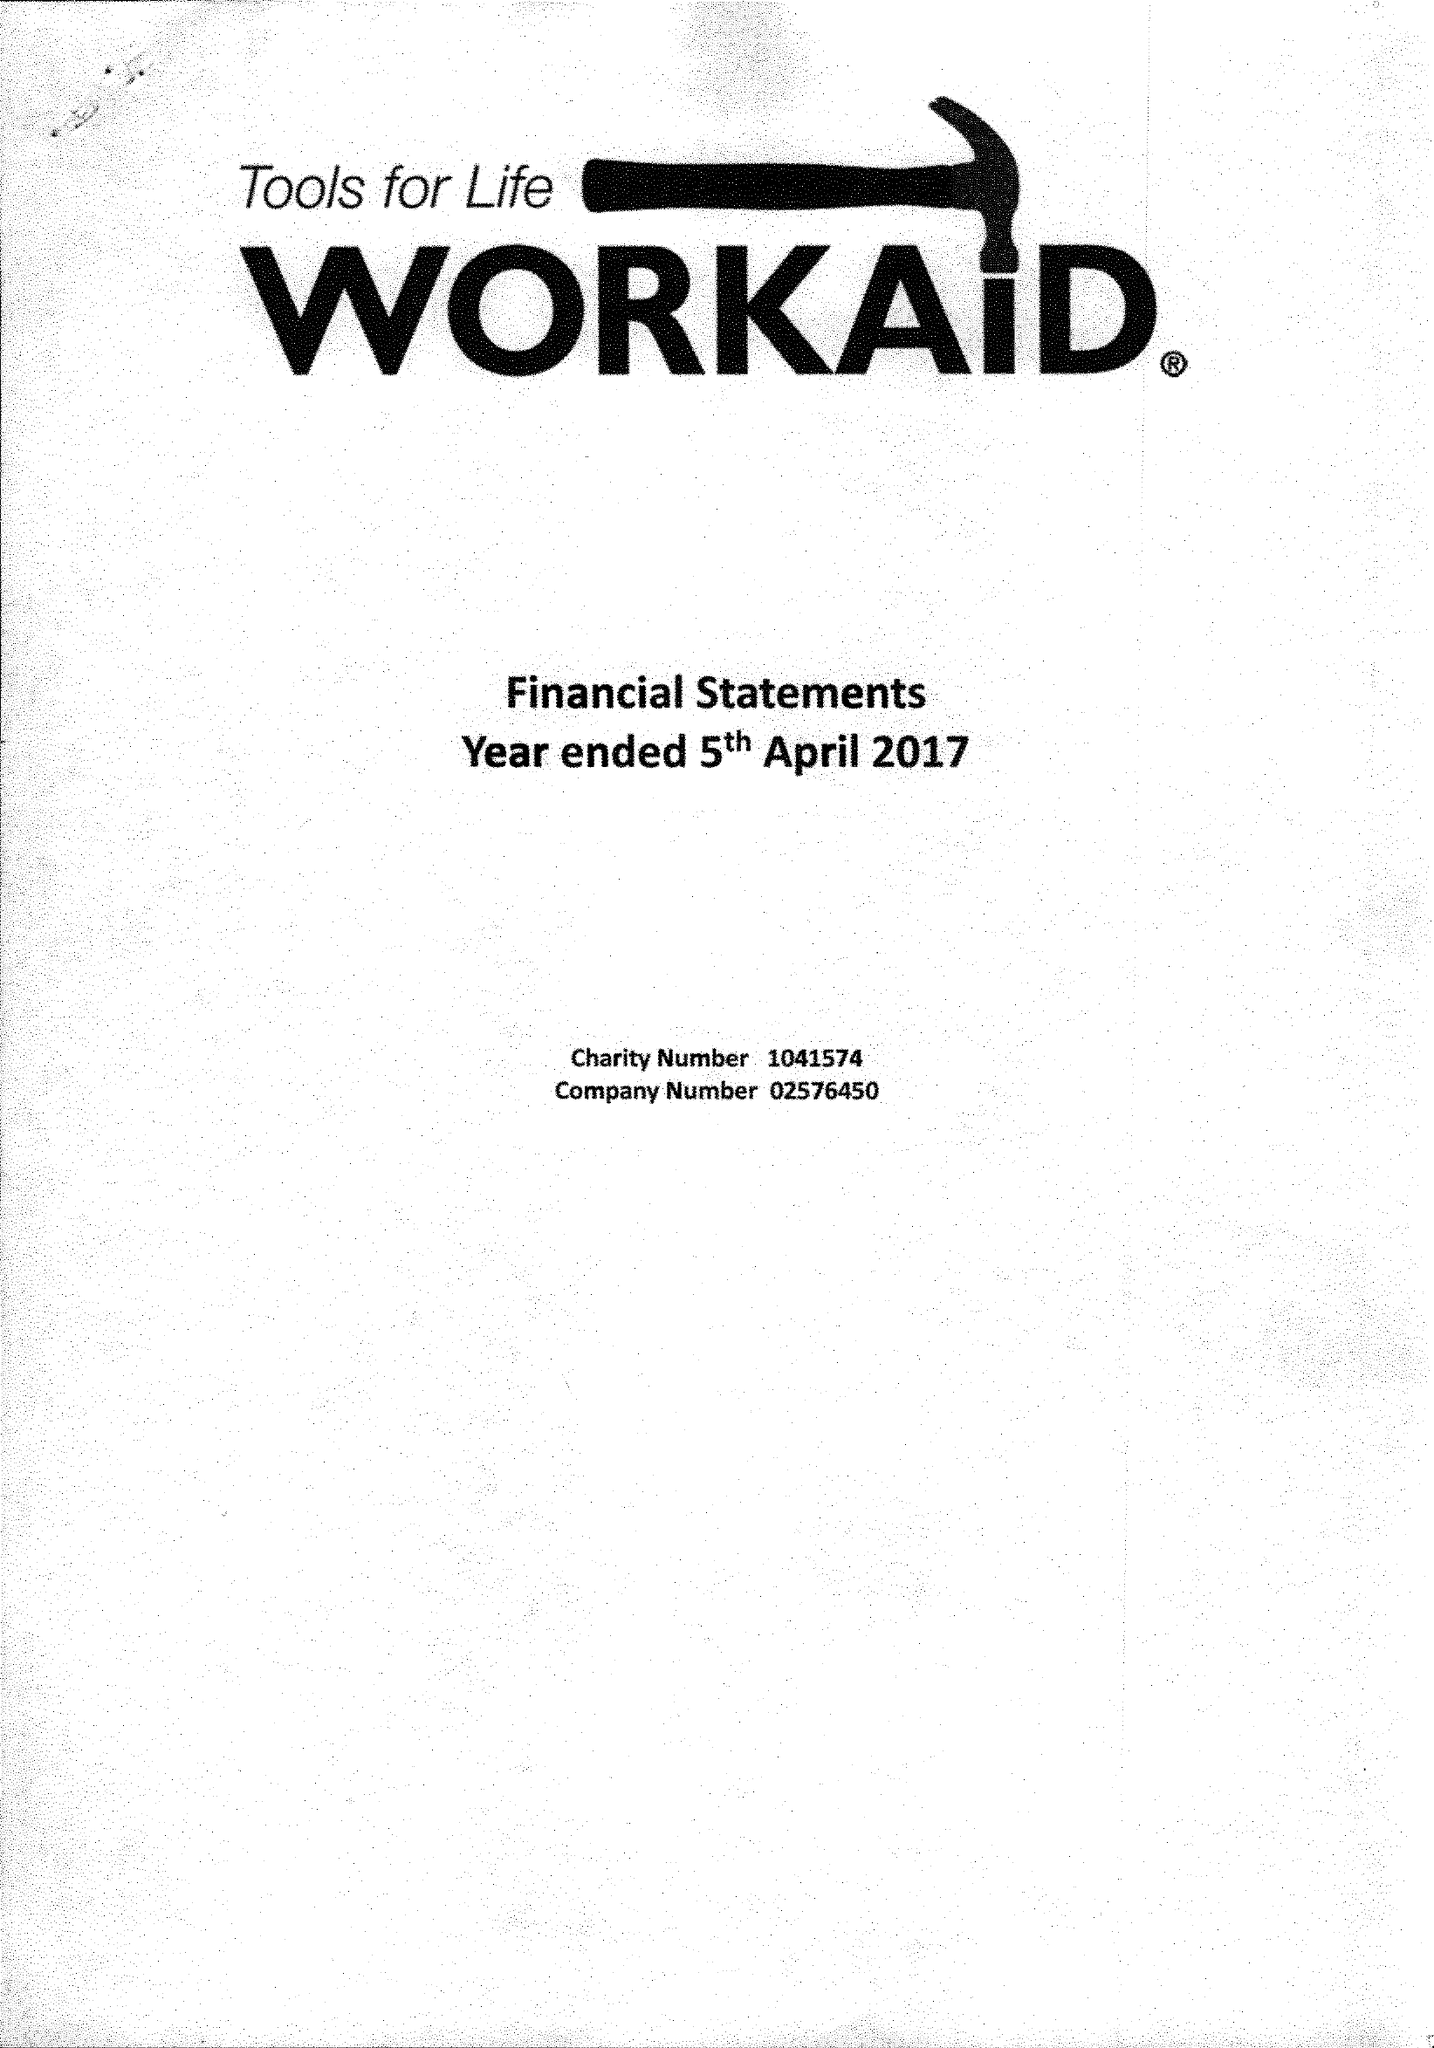What is the value for the spending_annually_in_british_pounds?
Answer the question using a single word or phrase. 310907.00 